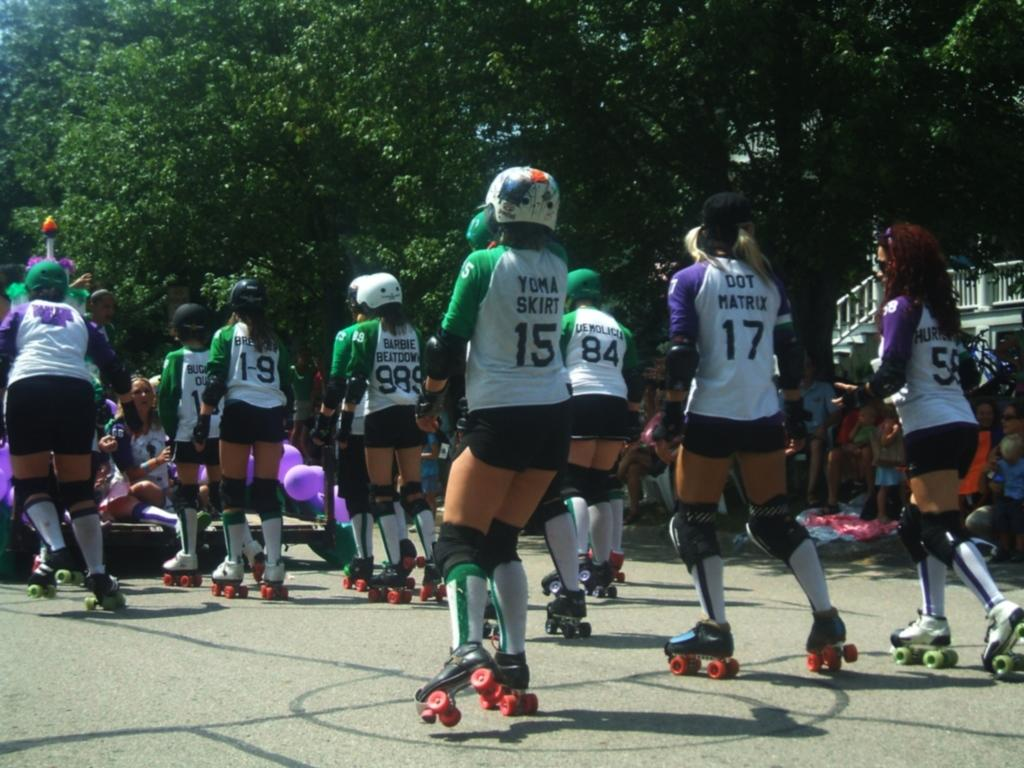Who or what is present in the image? There are people in the image. What type of footwear are the people wearing? The people are wearing skate shoes. What can be seen in the background of the image? There are trees in the background of the image. What riddle is being solved by the people in the image? There is no riddle present in the image; it simply shows people wearing skate shoes with trees in the background. 